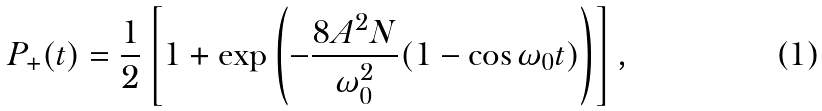Convert formula to latex. <formula><loc_0><loc_0><loc_500><loc_500>P _ { + } ( t ) = \frac { 1 } { 2 } \left [ 1 + \exp \left ( - \frac { 8 A ^ { 2 } N } { \omega _ { 0 } ^ { 2 } } ( 1 - \cos \omega _ { 0 } t ) \right ) \right ] ,</formula> 